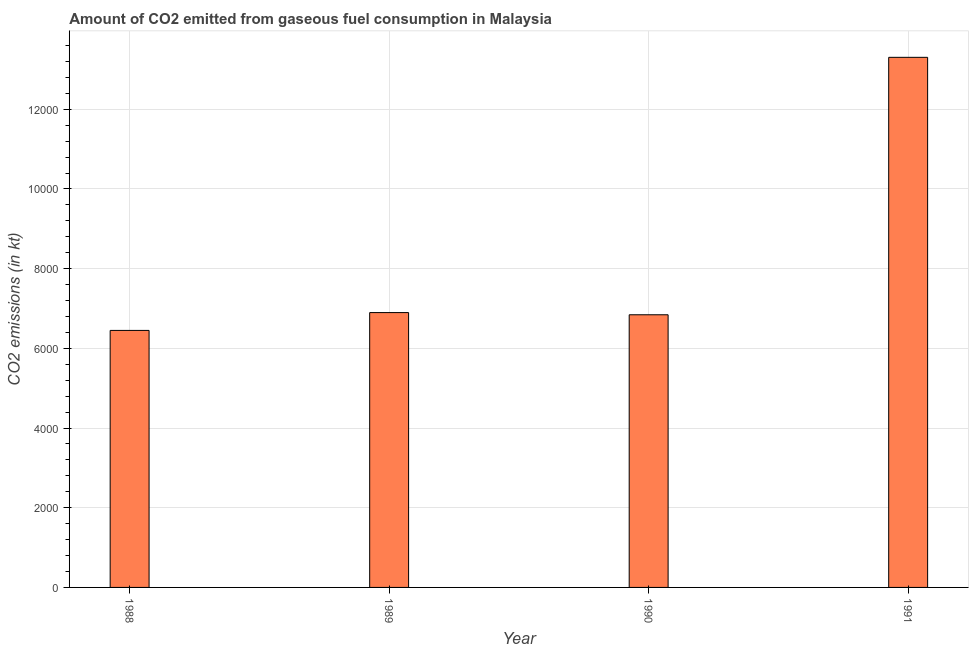Does the graph contain grids?
Provide a short and direct response. Yes. What is the title of the graph?
Provide a short and direct response. Amount of CO2 emitted from gaseous fuel consumption in Malaysia. What is the label or title of the Y-axis?
Make the answer very short. CO2 emissions (in kt). What is the co2 emissions from gaseous fuel consumption in 1991?
Your response must be concise. 1.33e+04. Across all years, what is the maximum co2 emissions from gaseous fuel consumption?
Give a very brief answer. 1.33e+04. Across all years, what is the minimum co2 emissions from gaseous fuel consumption?
Give a very brief answer. 6450.25. In which year was the co2 emissions from gaseous fuel consumption maximum?
Offer a terse response. 1991. In which year was the co2 emissions from gaseous fuel consumption minimum?
Keep it short and to the point. 1988. What is the sum of the co2 emissions from gaseous fuel consumption?
Make the answer very short. 3.35e+04. What is the difference between the co2 emissions from gaseous fuel consumption in 1989 and 1991?
Your response must be concise. -6406.25. What is the average co2 emissions from gaseous fuel consumption per year?
Your answer should be compact. 8373.59. What is the median co2 emissions from gaseous fuel consumption?
Provide a short and direct response. 6870.12. In how many years, is the co2 emissions from gaseous fuel consumption greater than 800 kt?
Provide a short and direct response. 4. What is the ratio of the co2 emissions from gaseous fuel consumption in 1988 to that in 1989?
Keep it short and to the point. 0.94. What is the difference between the highest and the second highest co2 emissions from gaseous fuel consumption?
Offer a very short reply. 6406.25. What is the difference between the highest and the lowest co2 emissions from gaseous fuel consumption?
Provide a succinct answer. 6853.62. How many years are there in the graph?
Your answer should be very brief. 4. What is the difference between two consecutive major ticks on the Y-axis?
Your response must be concise. 2000. What is the CO2 emissions (in kt) in 1988?
Provide a short and direct response. 6450.25. What is the CO2 emissions (in kt) in 1989?
Offer a very short reply. 6897.63. What is the CO2 emissions (in kt) in 1990?
Provide a short and direct response. 6842.62. What is the CO2 emissions (in kt) of 1991?
Give a very brief answer. 1.33e+04. What is the difference between the CO2 emissions (in kt) in 1988 and 1989?
Give a very brief answer. -447.37. What is the difference between the CO2 emissions (in kt) in 1988 and 1990?
Your answer should be very brief. -392.37. What is the difference between the CO2 emissions (in kt) in 1988 and 1991?
Ensure brevity in your answer.  -6853.62. What is the difference between the CO2 emissions (in kt) in 1989 and 1990?
Your answer should be very brief. 55.01. What is the difference between the CO2 emissions (in kt) in 1989 and 1991?
Give a very brief answer. -6406.25. What is the difference between the CO2 emissions (in kt) in 1990 and 1991?
Provide a short and direct response. -6461.25. What is the ratio of the CO2 emissions (in kt) in 1988 to that in 1989?
Provide a short and direct response. 0.94. What is the ratio of the CO2 emissions (in kt) in 1988 to that in 1990?
Provide a short and direct response. 0.94. What is the ratio of the CO2 emissions (in kt) in 1988 to that in 1991?
Keep it short and to the point. 0.48. What is the ratio of the CO2 emissions (in kt) in 1989 to that in 1991?
Make the answer very short. 0.52. What is the ratio of the CO2 emissions (in kt) in 1990 to that in 1991?
Keep it short and to the point. 0.51. 